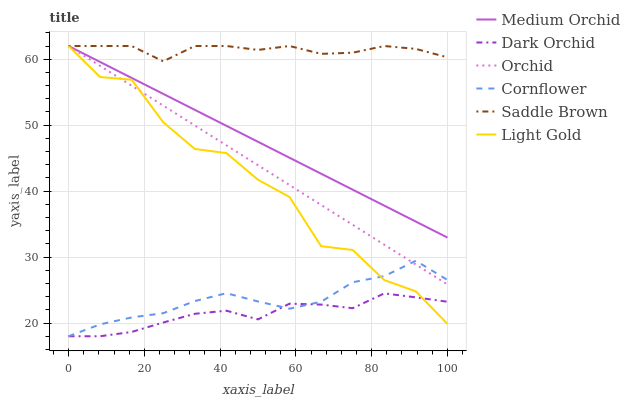Does Dark Orchid have the minimum area under the curve?
Answer yes or no. Yes. Does Saddle Brown have the maximum area under the curve?
Answer yes or no. Yes. Does Medium Orchid have the minimum area under the curve?
Answer yes or no. No. Does Medium Orchid have the maximum area under the curve?
Answer yes or no. No. Is Medium Orchid the smoothest?
Answer yes or no. Yes. Is Light Gold the roughest?
Answer yes or no. Yes. Is Dark Orchid the smoothest?
Answer yes or no. No. Is Dark Orchid the roughest?
Answer yes or no. No. Does Cornflower have the lowest value?
Answer yes or no. Yes. Does Medium Orchid have the lowest value?
Answer yes or no. No. Does Orchid have the highest value?
Answer yes or no. Yes. Does Dark Orchid have the highest value?
Answer yes or no. No. Is Dark Orchid less than Saddle Brown?
Answer yes or no. Yes. Is Medium Orchid greater than Dark Orchid?
Answer yes or no. Yes. Does Orchid intersect Light Gold?
Answer yes or no. Yes. Is Orchid less than Light Gold?
Answer yes or no. No. Is Orchid greater than Light Gold?
Answer yes or no. No. Does Dark Orchid intersect Saddle Brown?
Answer yes or no. No. 